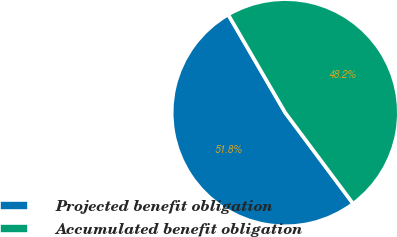Convert chart. <chart><loc_0><loc_0><loc_500><loc_500><pie_chart><fcel>Projected benefit obligation<fcel>Accumulated benefit obligation<nl><fcel>51.82%<fcel>48.18%<nl></chart> 